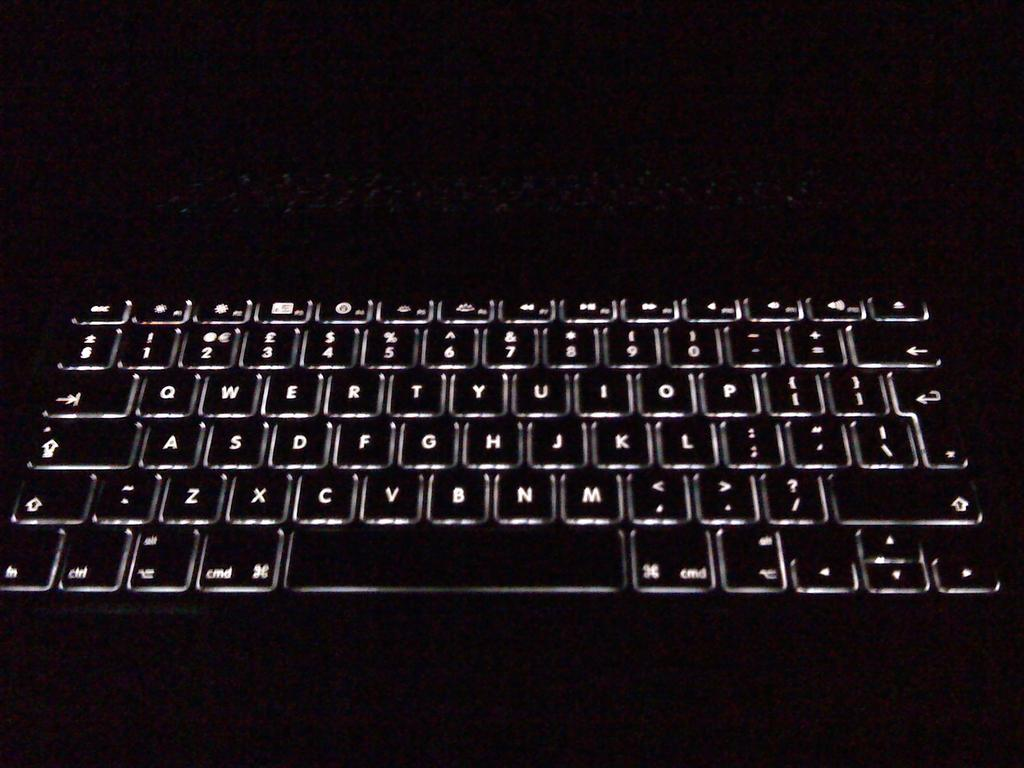<image>
Share a concise interpretation of the image provided. An image of a backlit computer keyboard with two keys on either side of the space bar that say cmd. 